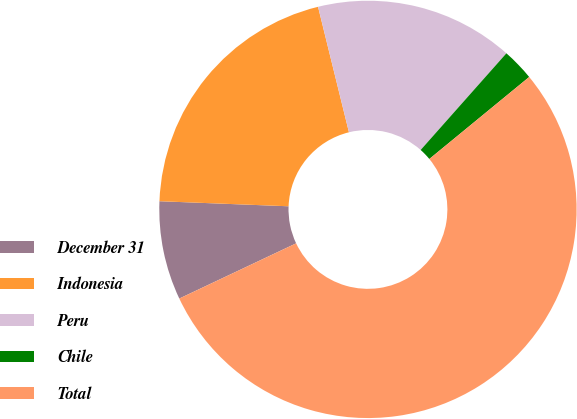Convert chart to OTSL. <chart><loc_0><loc_0><loc_500><loc_500><pie_chart><fcel>December 31<fcel>Indonesia<fcel>Peru<fcel>Chile<fcel>Total<nl><fcel>7.65%<fcel>20.53%<fcel>15.39%<fcel>2.51%<fcel>53.91%<nl></chart> 